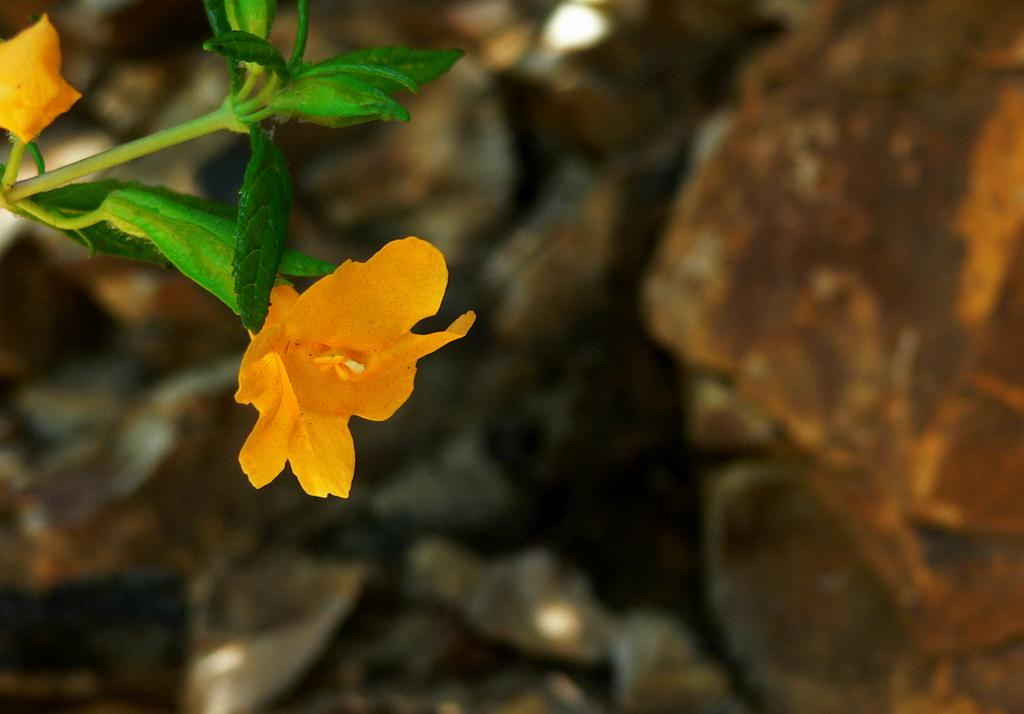What type of plant life is visible in the image? There are flowers and leaves in the image. Can you describe the background of the image? The background of the image is blurry. How does the beginner start their first meal in the image? There is no reference to a beginner or a meal in the image, so it is not possible to answer that question. 